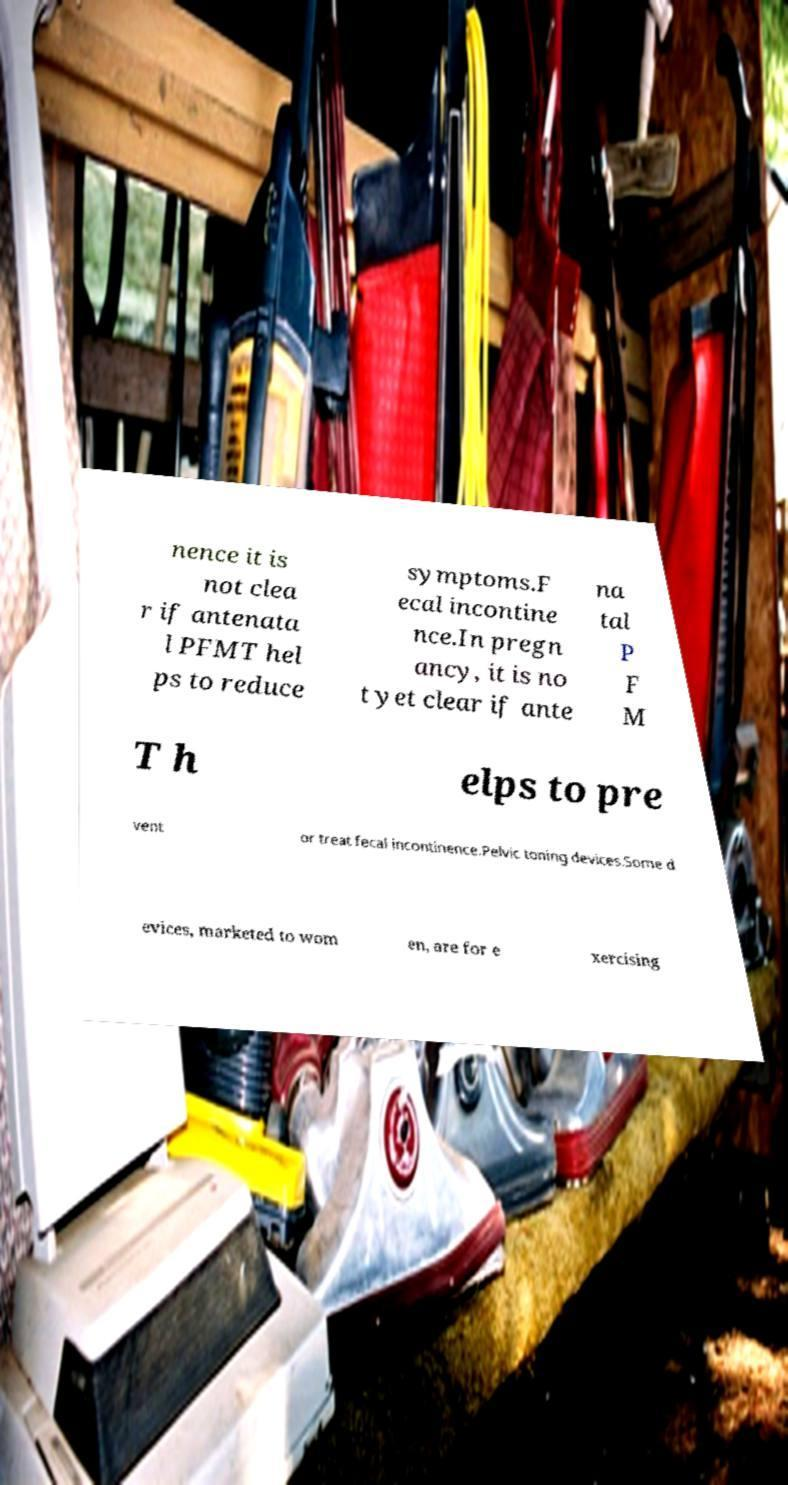Please identify and transcribe the text found in this image. nence it is not clea r if antenata l PFMT hel ps to reduce symptoms.F ecal incontine nce.In pregn ancy, it is no t yet clear if ante na tal P F M T h elps to pre vent or treat fecal incontinence.Pelvic toning devices.Some d evices, marketed to wom en, are for e xercising 